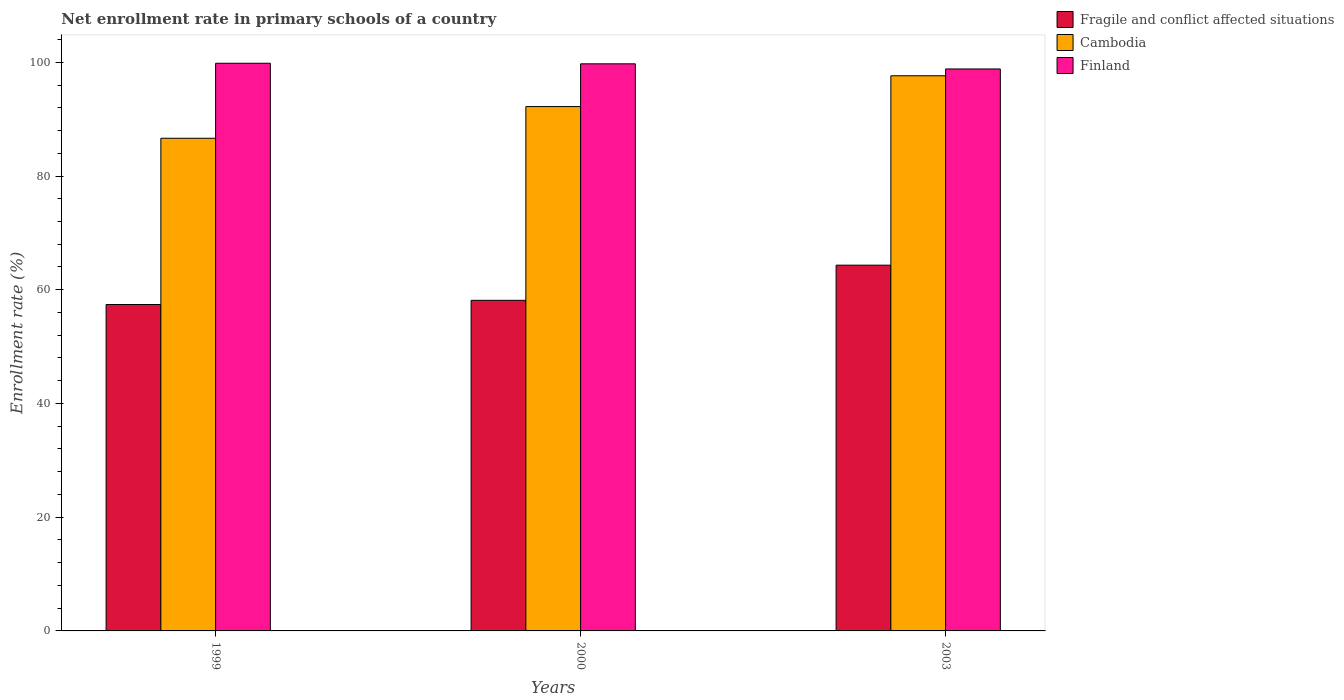Are the number of bars per tick equal to the number of legend labels?
Provide a succinct answer. Yes. Are the number of bars on each tick of the X-axis equal?
Make the answer very short. Yes. How many bars are there on the 2nd tick from the left?
Keep it short and to the point. 3. How many bars are there on the 2nd tick from the right?
Provide a short and direct response. 3. What is the enrollment rate in primary schools in Finland in 2003?
Your response must be concise. 98.83. Across all years, what is the maximum enrollment rate in primary schools in Cambodia?
Make the answer very short. 97.63. Across all years, what is the minimum enrollment rate in primary schools in Cambodia?
Offer a terse response. 86.64. In which year was the enrollment rate in primary schools in Finland maximum?
Offer a terse response. 1999. In which year was the enrollment rate in primary schools in Fragile and conflict affected situations minimum?
Ensure brevity in your answer.  1999. What is the total enrollment rate in primary schools in Finland in the graph?
Your answer should be compact. 298.39. What is the difference between the enrollment rate in primary schools in Finland in 1999 and that in 2003?
Provide a short and direct response. 1. What is the difference between the enrollment rate in primary schools in Finland in 2000 and the enrollment rate in primary schools in Cambodia in 2003?
Your response must be concise. 2.1. What is the average enrollment rate in primary schools in Finland per year?
Provide a succinct answer. 99.46. In the year 2000, what is the difference between the enrollment rate in primary schools in Fragile and conflict affected situations and enrollment rate in primary schools in Cambodia?
Make the answer very short. -34.07. In how many years, is the enrollment rate in primary schools in Cambodia greater than 92 %?
Keep it short and to the point. 2. What is the ratio of the enrollment rate in primary schools in Fragile and conflict affected situations in 1999 to that in 2000?
Your answer should be very brief. 0.99. What is the difference between the highest and the second highest enrollment rate in primary schools in Finland?
Ensure brevity in your answer.  0.1. What is the difference between the highest and the lowest enrollment rate in primary schools in Fragile and conflict affected situations?
Keep it short and to the point. 6.92. Is the sum of the enrollment rate in primary schools in Cambodia in 1999 and 2003 greater than the maximum enrollment rate in primary schools in Fragile and conflict affected situations across all years?
Provide a succinct answer. Yes. How many bars are there?
Your answer should be compact. 9. Are all the bars in the graph horizontal?
Make the answer very short. No. How many years are there in the graph?
Keep it short and to the point. 3. What is the difference between two consecutive major ticks on the Y-axis?
Your answer should be compact. 20. Are the values on the major ticks of Y-axis written in scientific E-notation?
Your answer should be compact. No. Does the graph contain any zero values?
Provide a short and direct response. No. Does the graph contain grids?
Give a very brief answer. No. Where does the legend appear in the graph?
Offer a very short reply. Top right. How are the legend labels stacked?
Keep it short and to the point. Vertical. What is the title of the graph?
Provide a short and direct response. Net enrollment rate in primary schools of a country. Does "Uzbekistan" appear as one of the legend labels in the graph?
Provide a succinct answer. No. What is the label or title of the X-axis?
Your response must be concise. Years. What is the label or title of the Y-axis?
Keep it short and to the point. Enrollment rate (%). What is the Enrollment rate (%) in Fragile and conflict affected situations in 1999?
Ensure brevity in your answer.  57.4. What is the Enrollment rate (%) in Cambodia in 1999?
Provide a succinct answer. 86.64. What is the Enrollment rate (%) in Finland in 1999?
Ensure brevity in your answer.  99.83. What is the Enrollment rate (%) of Fragile and conflict affected situations in 2000?
Your answer should be compact. 58.14. What is the Enrollment rate (%) in Cambodia in 2000?
Offer a terse response. 92.21. What is the Enrollment rate (%) of Finland in 2000?
Offer a terse response. 99.73. What is the Enrollment rate (%) of Fragile and conflict affected situations in 2003?
Offer a very short reply. 64.32. What is the Enrollment rate (%) of Cambodia in 2003?
Your answer should be compact. 97.63. What is the Enrollment rate (%) in Finland in 2003?
Make the answer very short. 98.83. Across all years, what is the maximum Enrollment rate (%) of Fragile and conflict affected situations?
Offer a terse response. 64.32. Across all years, what is the maximum Enrollment rate (%) in Cambodia?
Your answer should be very brief. 97.63. Across all years, what is the maximum Enrollment rate (%) of Finland?
Offer a very short reply. 99.83. Across all years, what is the minimum Enrollment rate (%) in Fragile and conflict affected situations?
Make the answer very short. 57.4. Across all years, what is the minimum Enrollment rate (%) of Cambodia?
Your response must be concise. 86.64. Across all years, what is the minimum Enrollment rate (%) in Finland?
Provide a short and direct response. 98.83. What is the total Enrollment rate (%) of Fragile and conflict affected situations in the graph?
Make the answer very short. 179.86. What is the total Enrollment rate (%) in Cambodia in the graph?
Give a very brief answer. 276.48. What is the total Enrollment rate (%) of Finland in the graph?
Provide a succinct answer. 298.39. What is the difference between the Enrollment rate (%) in Fragile and conflict affected situations in 1999 and that in 2000?
Your answer should be very brief. -0.74. What is the difference between the Enrollment rate (%) in Cambodia in 1999 and that in 2000?
Provide a short and direct response. -5.57. What is the difference between the Enrollment rate (%) of Finland in 1999 and that in 2000?
Offer a terse response. 0.1. What is the difference between the Enrollment rate (%) in Fragile and conflict affected situations in 1999 and that in 2003?
Keep it short and to the point. -6.92. What is the difference between the Enrollment rate (%) of Cambodia in 1999 and that in 2003?
Keep it short and to the point. -10.99. What is the difference between the Enrollment rate (%) in Finland in 1999 and that in 2003?
Make the answer very short. 1. What is the difference between the Enrollment rate (%) of Fragile and conflict affected situations in 2000 and that in 2003?
Keep it short and to the point. -6.18. What is the difference between the Enrollment rate (%) in Cambodia in 2000 and that in 2003?
Offer a very short reply. -5.42. What is the difference between the Enrollment rate (%) of Finland in 2000 and that in 2003?
Provide a short and direct response. 0.9. What is the difference between the Enrollment rate (%) of Fragile and conflict affected situations in 1999 and the Enrollment rate (%) of Cambodia in 2000?
Ensure brevity in your answer.  -34.81. What is the difference between the Enrollment rate (%) of Fragile and conflict affected situations in 1999 and the Enrollment rate (%) of Finland in 2000?
Offer a very short reply. -42.33. What is the difference between the Enrollment rate (%) of Cambodia in 1999 and the Enrollment rate (%) of Finland in 2000?
Provide a succinct answer. -13.09. What is the difference between the Enrollment rate (%) of Fragile and conflict affected situations in 1999 and the Enrollment rate (%) of Cambodia in 2003?
Your answer should be very brief. -40.23. What is the difference between the Enrollment rate (%) of Fragile and conflict affected situations in 1999 and the Enrollment rate (%) of Finland in 2003?
Provide a succinct answer. -41.43. What is the difference between the Enrollment rate (%) in Cambodia in 1999 and the Enrollment rate (%) in Finland in 2003?
Make the answer very short. -12.19. What is the difference between the Enrollment rate (%) of Fragile and conflict affected situations in 2000 and the Enrollment rate (%) of Cambodia in 2003?
Give a very brief answer. -39.49. What is the difference between the Enrollment rate (%) of Fragile and conflict affected situations in 2000 and the Enrollment rate (%) of Finland in 2003?
Your answer should be compact. -40.69. What is the difference between the Enrollment rate (%) in Cambodia in 2000 and the Enrollment rate (%) in Finland in 2003?
Ensure brevity in your answer.  -6.61. What is the average Enrollment rate (%) of Fragile and conflict affected situations per year?
Your response must be concise. 59.95. What is the average Enrollment rate (%) in Cambodia per year?
Provide a succinct answer. 92.16. What is the average Enrollment rate (%) in Finland per year?
Give a very brief answer. 99.46. In the year 1999, what is the difference between the Enrollment rate (%) of Fragile and conflict affected situations and Enrollment rate (%) of Cambodia?
Provide a succinct answer. -29.24. In the year 1999, what is the difference between the Enrollment rate (%) of Fragile and conflict affected situations and Enrollment rate (%) of Finland?
Your answer should be very brief. -42.43. In the year 1999, what is the difference between the Enrollment rate (%) in Cambodia and Enrollment rate (%) in Finland?
Give a very brief answer. -13.19. In the year 2000, what is the difference between the Enrollment rate (%) of Fragile and conflict affected situations and Enrollment rate (%) of Cambodia?
Your response must be concise. -34.07. In the year 2000, what is the difference between the Enrollment rate (%) of Fragile and conflict affected situations and Enrollment rate (%) of Finland?
Provide a succinct answer. -41.59. In the year 2000, what is the difference between the Enrollment rate (%) of Cambodia and Enrollment rate (%) of Finland?
Give a very brief answer. -7.52. In the year 2003, what is the difference between the Enrollment rate (%) in Fragile and conflict affected situations and Enrollment rate (%) in Cambodia?
Keep it short and to the point. -33.31. In the year 2003, what is the difference between the Enrollment rate (%) in Fragile and conflict affected situations and Enrollment rate (%) in Finland?
Offer a terse response. -34.51. In the year 2003, what is the difference between the Enrollment rate (%) of Cambodia and Enrollment rate (%) of Finland?
Ensure brevity in your answer.  -1.2. What is the ratio of the Enrollment rate (%) in Fragile and conflict affected situations in 1999 to that in 2000?
Give a very brief answer. 0.99. What is the ratio of the Enrollment rate (%) in Cambodia in 1999 to that in 2000?
Provide a succinct answer. 0.94. What is the ratio of the Enrollment rate (%) of Fragile and conflict affected situations in 1999 to that in 2003?
Offer a terse response. 0.89. What is the ratio of the Enrollment rate (%) of Cambodia in 1999 to that in 2003?
Offer a very short reply. 0.89. What is the ratio of the Enrollment rate (%) of Fragile and conflict affected situations in 2000 to that in 2003?
Keep it short and to the point. 0.9. What is the ratio of the Enrollment rate (%) in Cambodia in 2000 to that in 2003?
Your answer should be very brief. 0.94. What is the ratio of the Enrollment rate (%) of Finland in 2000 to that in 2003?
Keep it short and to the point. 1.01. What is the difference between the highest and the second highest Enrollment rate (%) in Fragile and conflict affected situations?
Offer a very short reply. 6.18. What is the difference between the highest and the second highest Enrollment rate (%) of Cambodia?
Offer a very short reply. 5.42. What is the difference between the highest and the second highest Enrollment rate (%) of Finland?
Offer a terse response. 0.1. What is the difference between the highest and the lowest Enrollment rate (%) in Fragile and conflict affected situations?
Keep it short and to the point. 6.92. What is the difference between the highest and the lowest Enrollment rate (%) in Cambodia?
Your answer should be very brief. 10.99. What is the difference between the highest and the lowest Enrollment rate (%) of Finland?
Your answer should be compact. 1. 